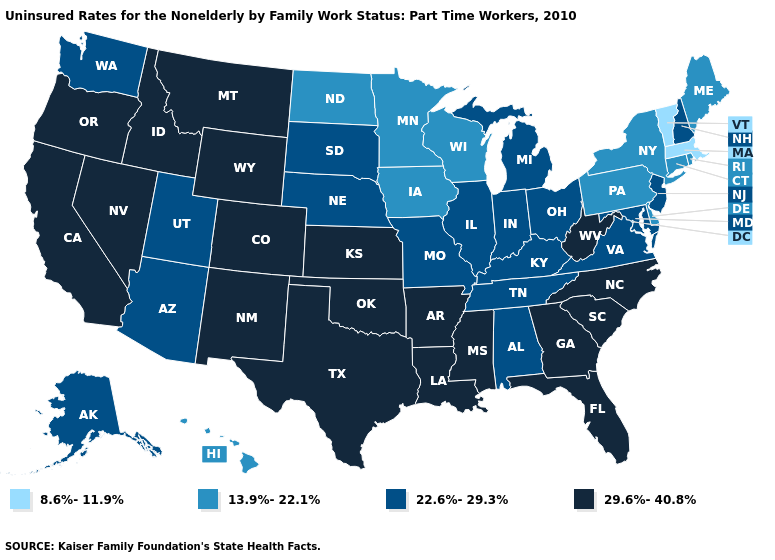Name the states that have a value in the range 22.6%-29.3%?
Keep it brief. Alabama, Alaska, Arizona, Illinois, Indiana, Kentucky, Maryland, Michigan, Missouri, Nebraska, New Hampshire, New Jersey, Ohio, South Dakota, Tennessee, Utah, Virginia, Washington. Does Virginia have the highest value in the South?
Concise answer only. No. Name the states that have a value in the range 29.6%-40.8%?
Keep it brief. Arkansas, California, Colorado, Florida, Georgia, Idaho, Kansas, Louisiana, Mississippi, Montana, Nevada, New Mexico, North Carolina, Oklahoma, Oregon, South Carolina, Texas, West Virginia, Wyoming. What is the highest value in the USA?
Keep it brief. 29.6%-40.8%. Does Wyoming have the lowest value in the West?
Give a very brief answer. No. What is the lowest value in the MidWest?
Be succinct. 13.9%-22.1%. What is the lowest value in the South?
Quick response, please. 13.9%-22.1%. Does Missouri have the lowest value in the MidWest?
Keep it brief. No. What is the value of North Carolina?
Give a very brief answer. 29.6%-40.8%. Does Oklahoma have the same value as Connecticut?
Be succinct. No. Does Kentucky have the highest value in the South?
Answer briefly. No. Name the states that have a value in the range 22.6%-29.3%?
Concise answer only. Alabama, Alaska, Arizona, Illinois, Indiana, Kentucky, Maryland, Michigan, Missouri, Nebraska, New Hampshire, New Jersey, Ohio, South Dakota, Tennessee, Utah, Virginia, Washington. Which states have the highest value in the USA?
Be succinct. Arkansas, California, Colorado, Florida, Georgia, Idaho, Kansas, Louisiana, Mississippi, Montana, Nevada, New Mexico, North Carolina, Oklahoma, Oregon, South Carolina, Texas, West Virginia, Wyoming. Which states have the lowest value in the South?
Keep it brief. Delaware. What is the lowest value in the MidWest?
Short answer required. 13.9%-22.1%. 